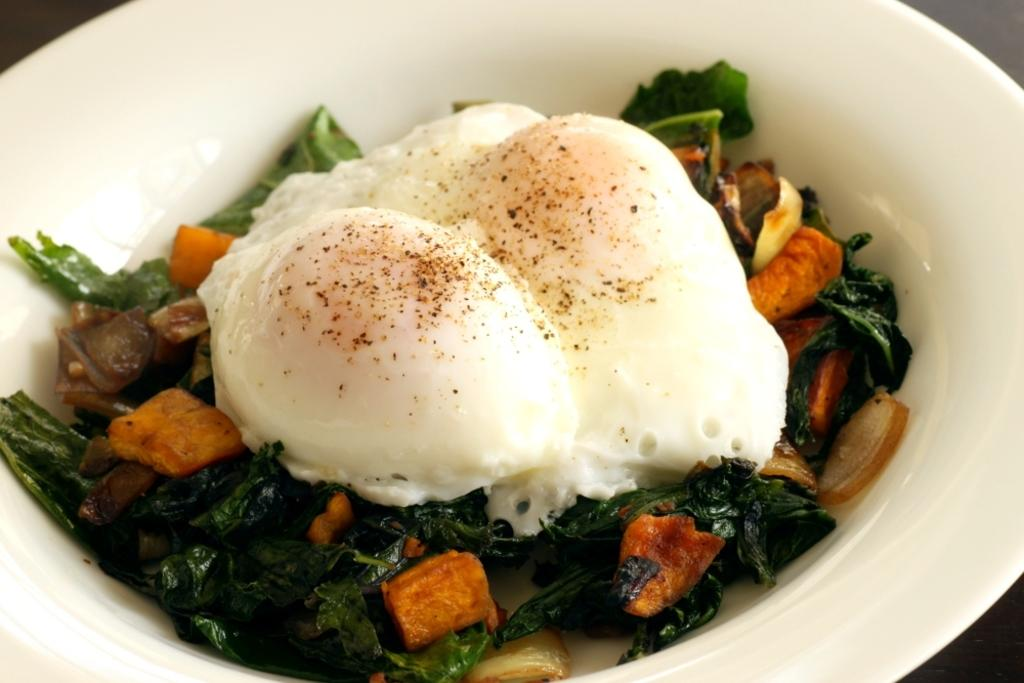What is placed in a bowl in the image? There is an eatable item placed in a bowl in the image. Can you see a seashore in the image? There is no seashore present in the image; it only features an eatable item placed in a bowl. What type of cloth is draped over the bowl in the image? There is no cloth present in the image; it only features an eatable item placed in a bowl. 